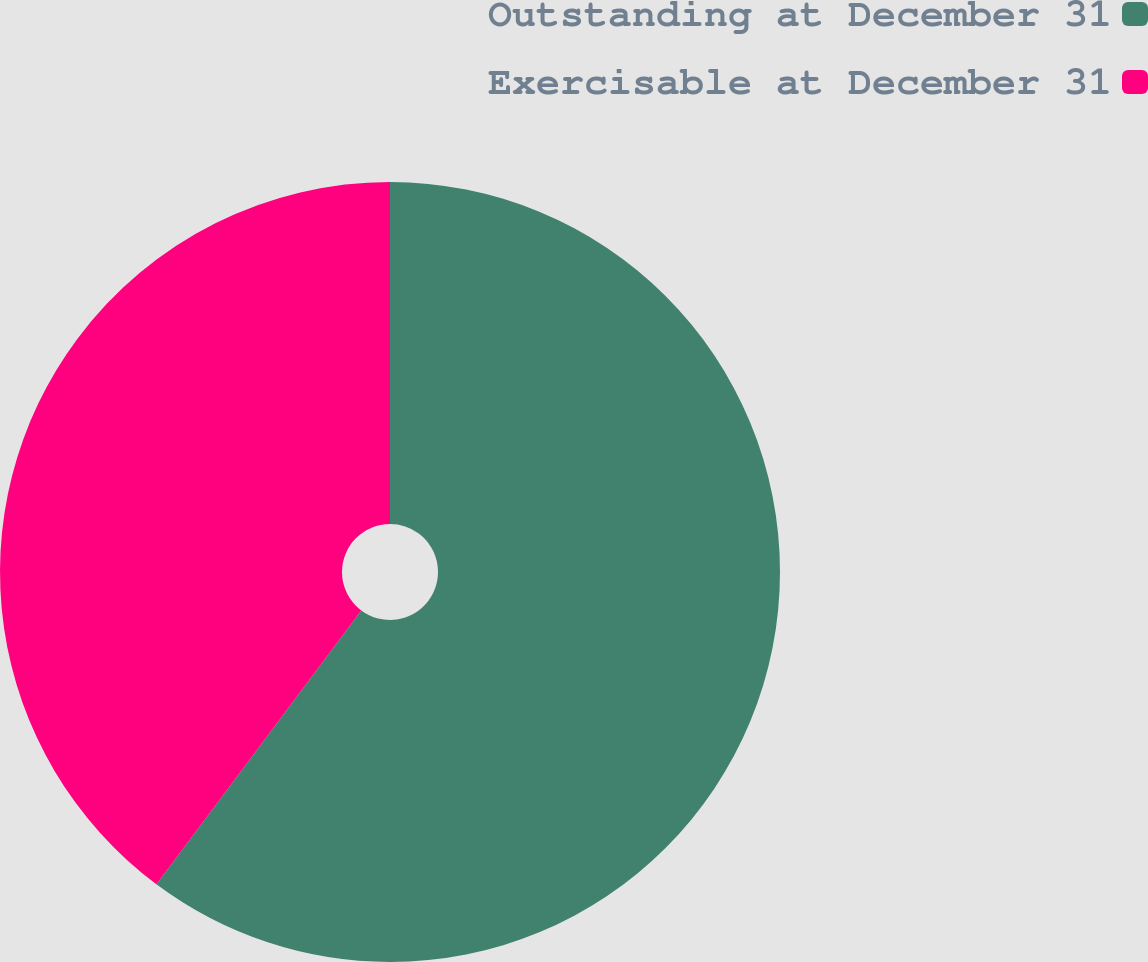<chart> <loc_0><loc_0><loc_500><loc_500><pie_chart><fcel>Outstanding at December 31<fcel>Exercisable at December 31<nl><fcel>60.22%<fcel>39.78%<nl></chart> 